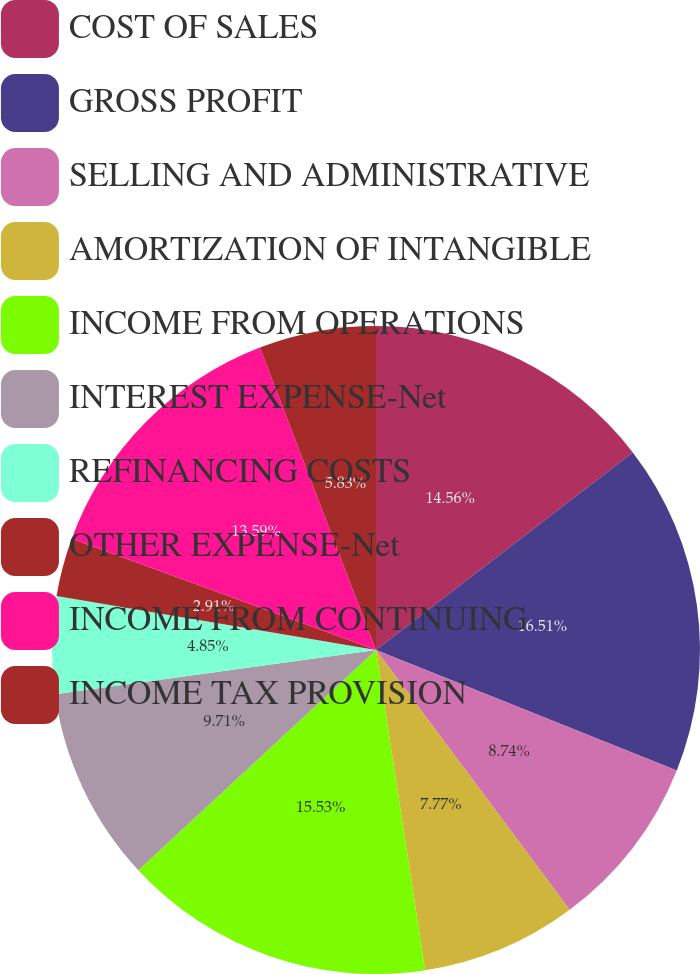<chart> <loc_0><loc_0><loc_500><loc_500><pie_chart><fcel>COST OF SALES<fcel>GROSS PROFIT<fcel>SELLING AND ADMINISTRATIVE<fcel>AMORTIZATION OF INTANGIBLE<fcel>INCOME FROM OPERATIONS<fcel>INTEREST EXPENSE-Net<fcel>REFINANCING COSTS<fcel>OTHER EXPENSE-Net<fcel>INCOME FROM CONTINUING<fcel>INCOME TAX PROVISION<nl><fcel>14.56%<fcel>16.5%<fcel>8.74%<fcel>7.77%<fcel>15.53%<fcel>9.71%<fcel>4.85%<fcel>2.91%<fcel>13.59%<fcel>5.83%<nl></chart> 